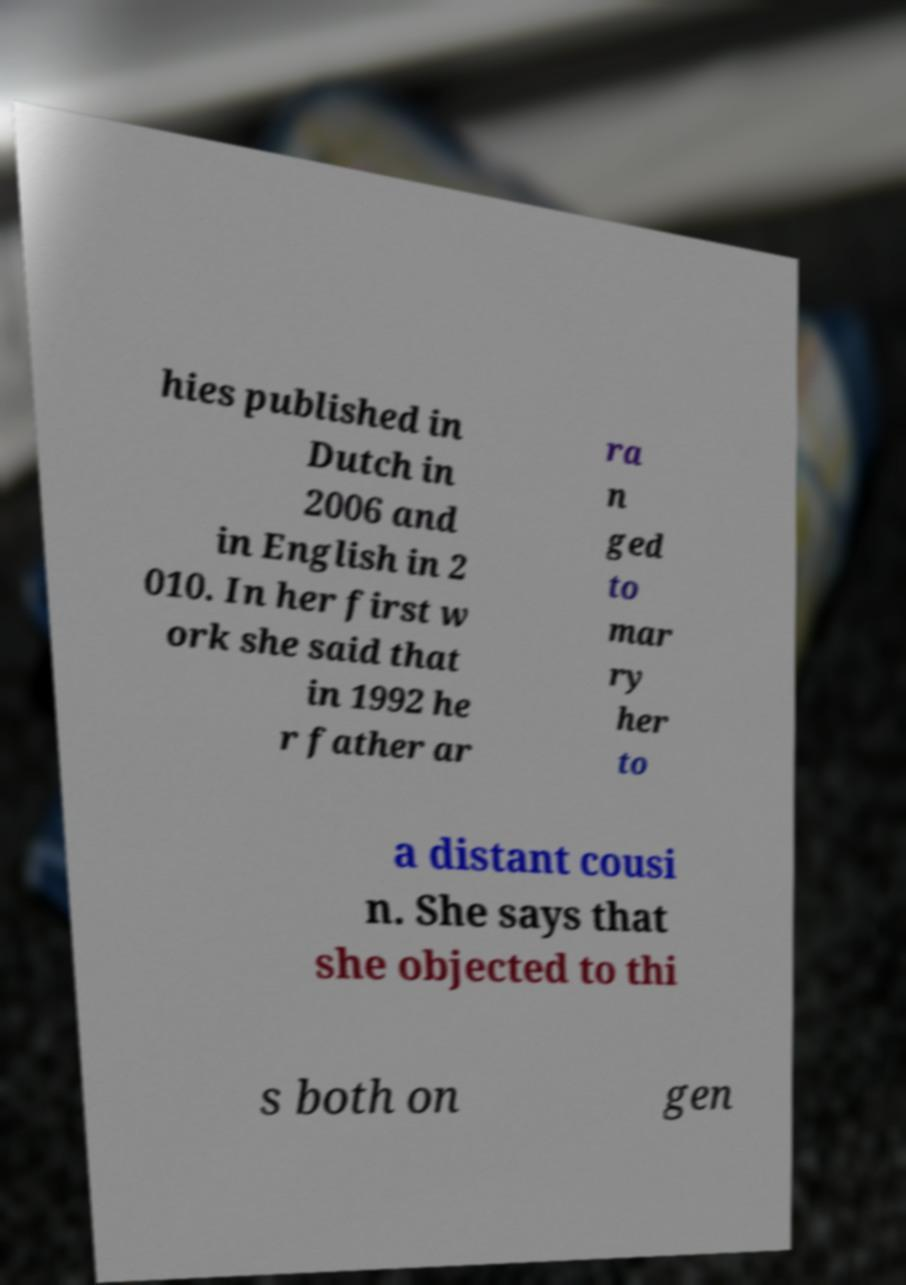Could you extract and type out the text from this image? hies published in Dutch in 2006 and in English in 2 010. In her first w ork she said that in 1992 he r father ar ra n ged to mar ry her to a distant cousi n. She says that she objected to thi s both on gen 